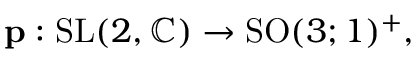<formula> <loc_0><loc_0><loc_500><loc_500>p \colon { S L } ( 2 , \mathbb { C } ) \to { S O } ( 3 ; 1 ) ^ { + } ,</formula> 